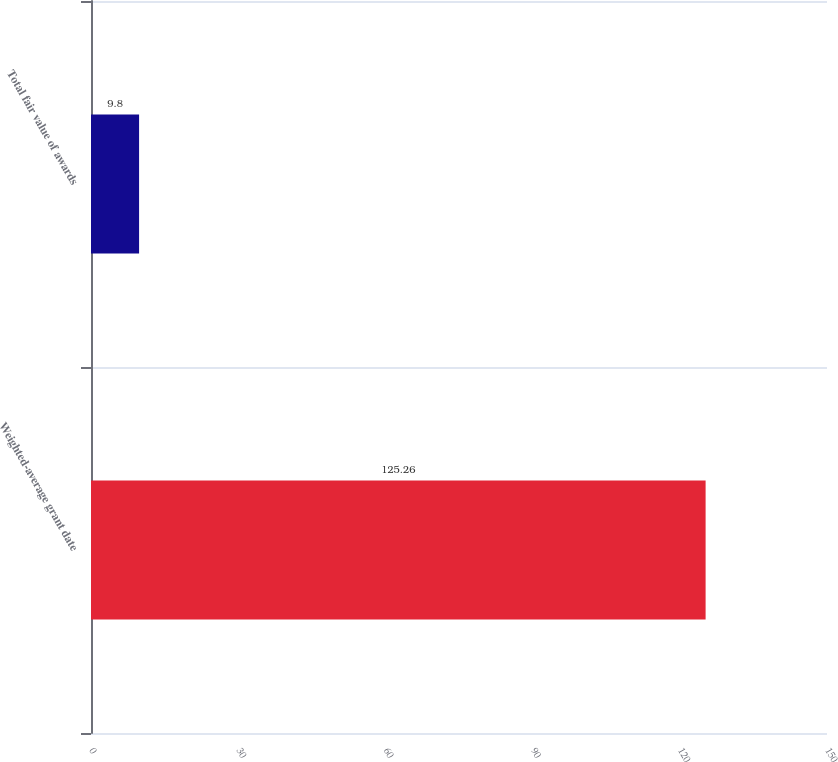Convert chart. <chart><loc_0><loc_0><loc_500><loc_500><bar_chart><fcel>Weighted-average grant date<fcel>Total fair value of awards<nl><fcel>125.26<fcel>9.8<nl></chart> 